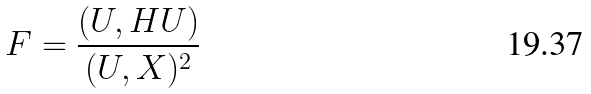Convert formula to latex. <formula><loc_0><loc_0><loc_500><loc_500>F = \frac { ( U , H U ) } { ( U , X ) ^ { 2 } }</formula> 